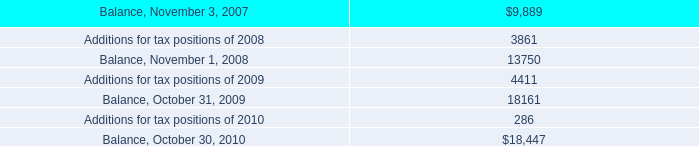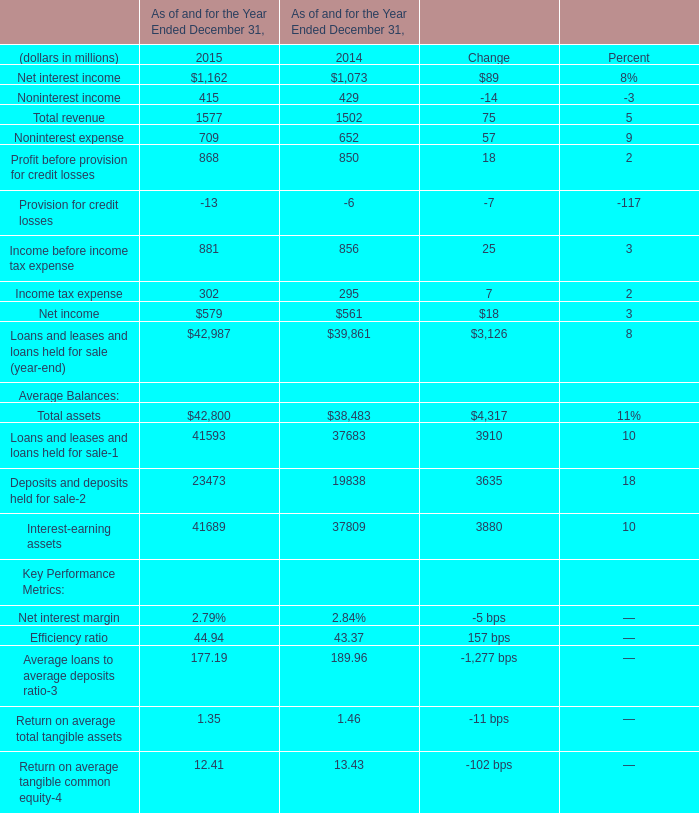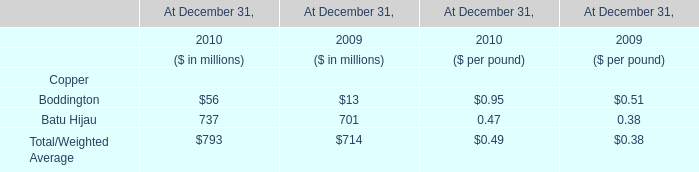by what amount does the interest and penalties expense exceed the payment for interest and penalties in 2010? 
Computations: (9.8 - 8.0)
Answer: 1.8. 